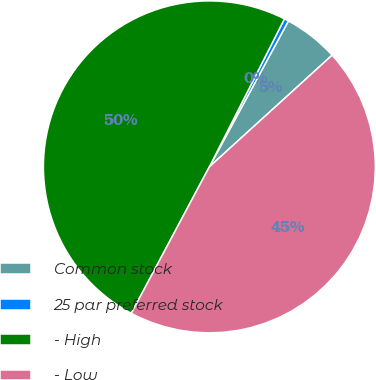Convert chart to OTSL. <chart><loc_0><loc_0><loc_500><loc_500><pie_chart><fcel>Common stock<fcel>25 par preferred stock<fcel>- High<fcel>- Low<nl><fcel>5.35%<fcel>0.43%<fcel>49.68%<fcel>44.54%<nl></chart> 